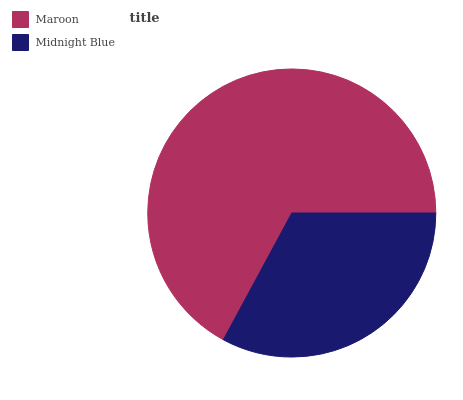Is Midnight Blue the minimum?
Answer yes or no. Yes. Is Maroon the maximum?
Answer yes or no. Yes. Is Midnight Blue the maximum?
Answer yes or no. No. Is Maroon greater than Midnight Blue?
Answer yes or no. Yes. Is Midnight Blue less than Maroon?
Answer yes or no. Yes. Is Midnight Blue greater than Maroon?
Answer yes or no. No. Is Maroon less than Midnight Blue?
Answer yes or no. No. Is Maroon the high median?
Answer yes or no. Yes. Is Midnight Blue the low median?
Answer yes or no. Yes. Is Midnight Blue the high median?
Answer yes or no. No. Is Maroon the low median?
Answer yes or no. No. 